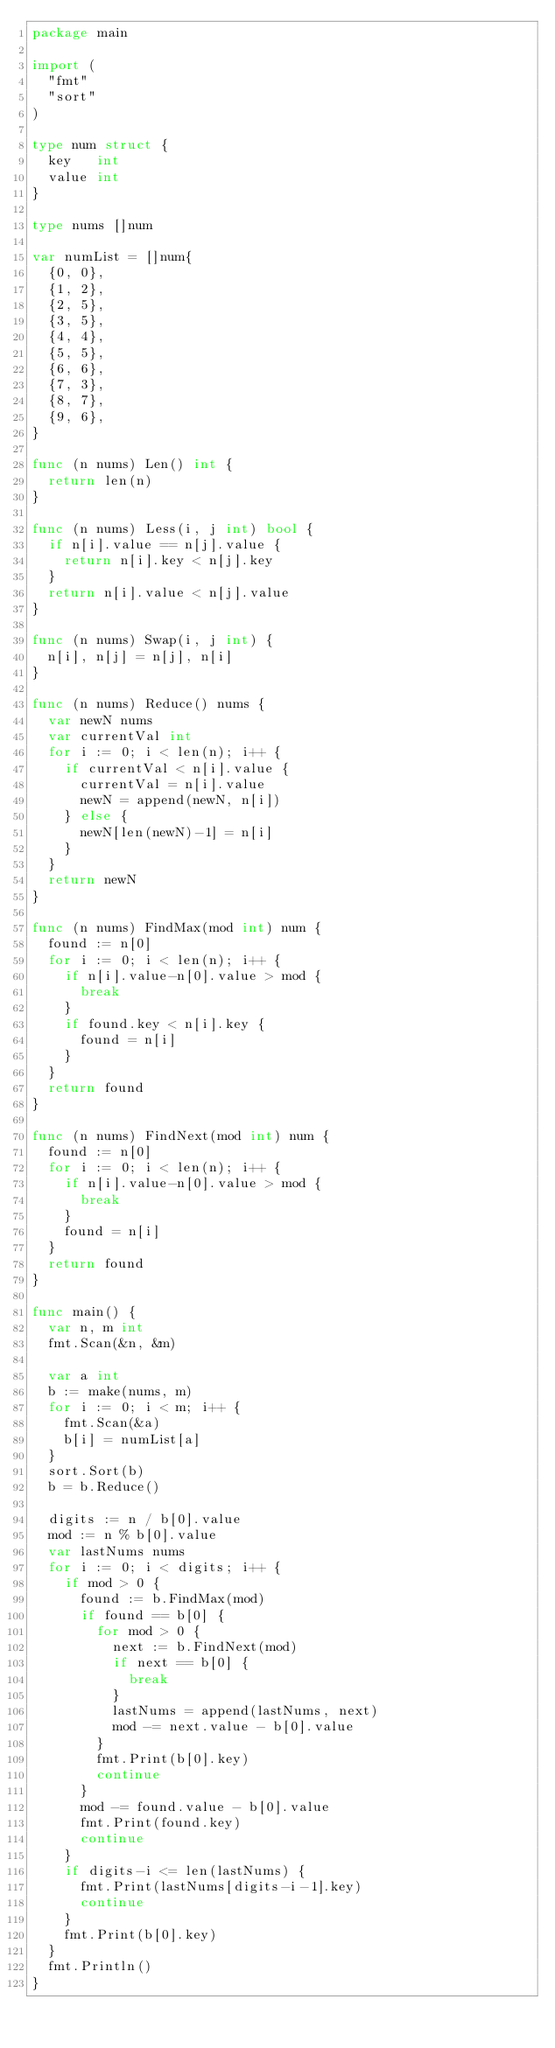Convert code to text. <code><loc_0><loc_0><loc_500><loc_500><_Go_>package main

import (
	"fmt"
	"sort"
)

type num struct {
	key   int
	value int
}

type nums []num

var numList = []num{
	{0, 0},
	{1, 2},
	{2, 5},
	{3, 5},
	{4, 4},
	{5, 5},
	{6, 6},
	{7, 3},
	{8, 7},
	{9, 6},
}

func (n nums) Len() int {
	return len(n)
}

func (n nums) Less(i, j int) bool {
	if n[i].value == n[j].value {
		return n[i].key < n[j].key
	}
	return n[i].value < n[j].value
}

func (n nums) Swap(i, j int) {
	n[i], n[j] = n[j], n[i]
}

func (n nums) Reduce() nums {
	var newN nums
	var currentVal int
	for i := 0; i < len(n); i++ {
		if currentVal < n[i].value {
			currentVal = n[i].value
			newN = append(newN, n[i])
		} else {
			newN[len(newN)-1] = n[i]
		}
	}
	return newN
}

func (n nums) FindMax(mod int) num {
	found := n[0]
	for i := 0; i < len(n); i++ {
		if n[i].value-n[0].value > mod {
			break
		}
		if found.key < n[i].key {
			found = n[i]
		}
	}
	return found
}

func (n nums) FindNext(mod int) num {
	found := n[0]
	for i := 0; i < len(n); i++ {
		if n[i].value-n[0].value > mod {
			break
		}
		found = n[i]
	}
	return found
}

func main() {
	var n, m int
	fmt.Scan(&n, &m)

	var a int
	b := make(nums, m)
	for i := 0; i < m; i++ {
		fmt.Scan(&a)
		b[i] = numList[a]
	}
	sort.Sort(b)
	b = b.Reduce()

	digits := n / b[0].value
	mod := n % b[0].value
	var lastNums nums
	for i := 0; i < digits; i++ {
		if mod > 0 {
			found := b.FindMax(mod)
			if found == b[0] {
				for mod > 0 {
					next := b.FindNext(mod)
					if next == b[0] {
						break
					}
					lastNums = append(lastNums, next)
					mod -= next.value - b[0].value
				}
				fmt.Print(b[0].key)
				continue
			}
			mod -= found.value - b[0].value
			fmt.Print(found.key)
			continue
		}
		if digits-i <= len(lastNums) {
			fmt.Print(lastNums[digits-i-1].key)
			continue
		}
		fmt.Print(b[0].key)
	}
	fmt.Println()
}</code> 